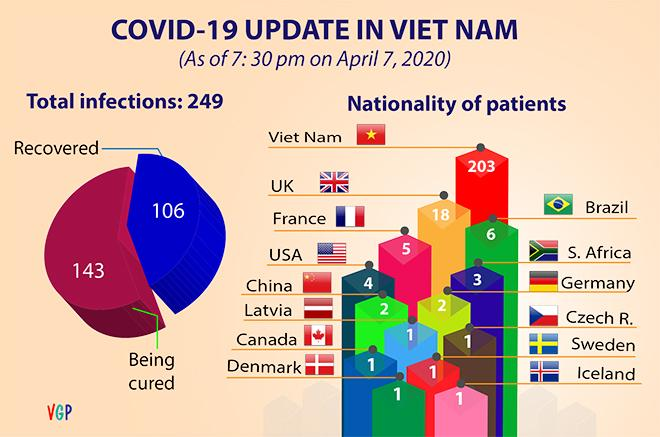Point out several critical features in this image. Vietnam has the highest number of patients in the country. In Vietnam, there are 6 countries where the number of patients with a value of 1 is high. In terms of share of recovery or cure, which method has the highest percentage? 